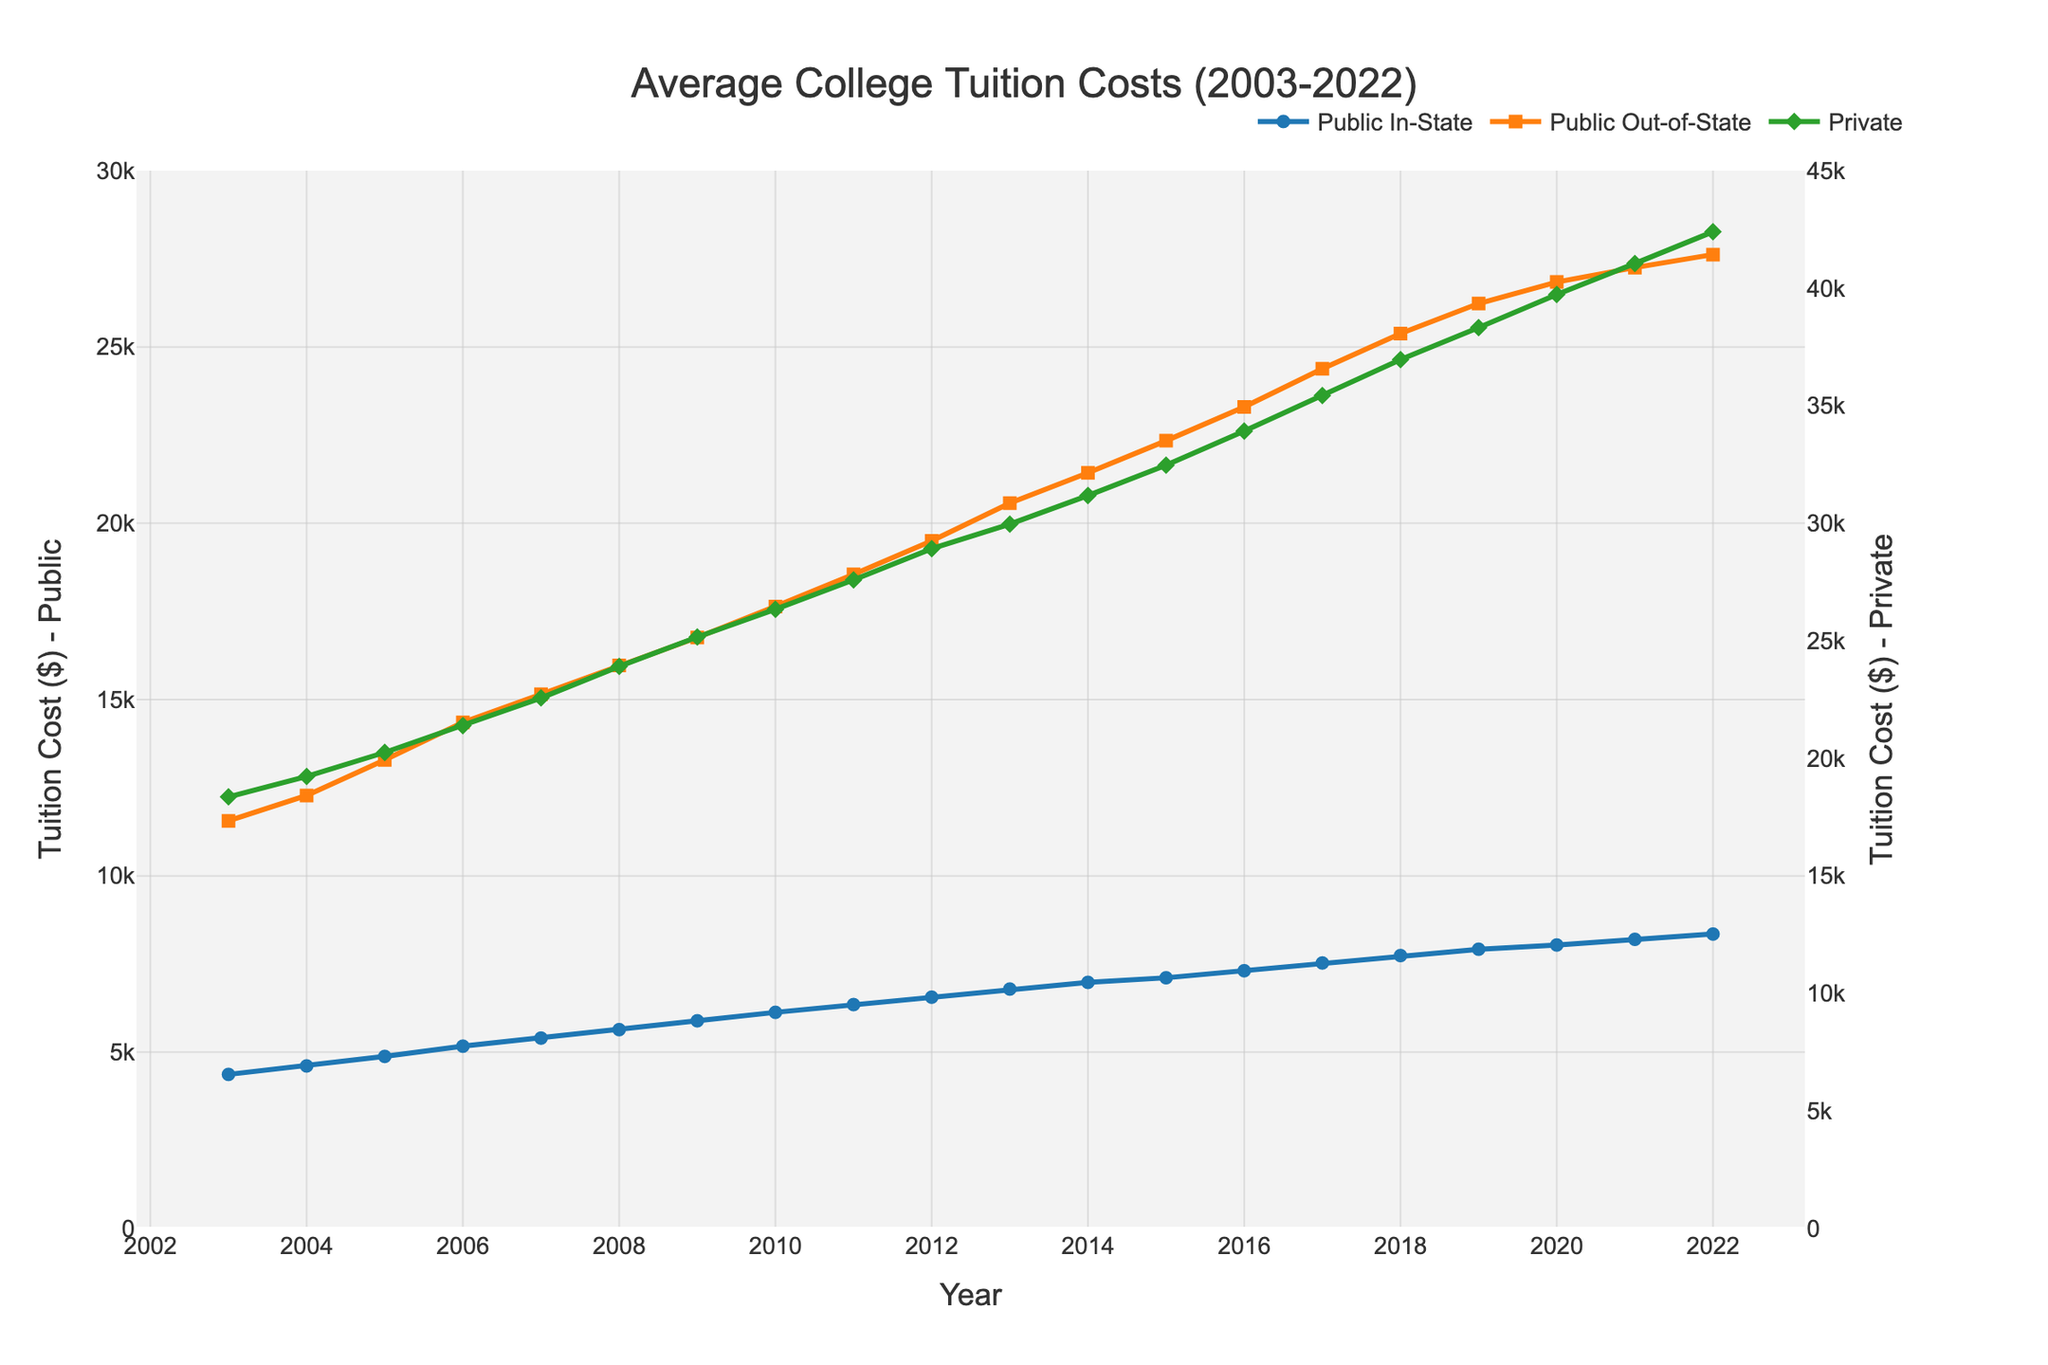What's the title of the figure? The title of the figure is written at the top center of the plot and reads "Average College Tuition Costs (2003-2022)."
Answer: Average College Tuition Costs (2003-2022) How many institution types are displayed in the figure? The figure shows plots for three different institution types: Public In-State, Public Out-of-State, and Private, which are labeled in the legend.
Answer: Three Which institution type has the highest tuition cost in 2022? The Private institution type is at the topmost line on the plot in 2022, indicating it has the highest tuition cost out of the three institution types.
Answer: Private What is the tuition cost for Public In-State institutions in 2003? To find the tuition cost for Public In-State in 2003, refer to the point on the Public In-State line (blue) that corresponds to the year 2003 on the x-axis.
Answer: $4,370 How has the tuition cost for Public Out-of-State institutions changed from 2003 to 2022? The tuition cost for Public Out-of-State institutions has increased over time: start by looking at the value in 2003 ($11,560) and then at the value in 2022 ($27,620). Subtract the 2003 value from the 2022 value to find the change.
Answer: $16,060 Which year saw the steepest increase in tuition cost for Private institutions? To determine the steepest increase, examine the changes in the slope of the Private institution line (green). The largest vertical difference between the markers from one year to the next indicates the steepest increase.
Answer: 2016 to 2017 Between Public In-State and Public Out-of-State institutions, which had a higher percentage increase in tuition cost from 2003 to 2022? Calculate percentage increase using the formula [(2022 value - 2003 value) / 2003 value] * 100. For Public In-State: [($8,350 - $4,370) / $4,370] * 100 and for Public Out-of-State: [($27,620 - $11,560) / $11,560] * 100. Compare the percentages to determine which is higher.
Answer: Public Out-of-State What's the average tuition cost for Private institutions over the years shown? Sum the tuition costs for Private institutions across all the listed years and divide by the number of years (20). Sum = 18360 + 19230 + 20250 + 21390 + 22570 + 23910 + 25160 + 26340 + 27590 + 28920 + 29960 + 31180 + 32470 + 33920 + 35430 + 36960 + 38320 + 39730 + 41050 + 42400. Average = Sum / 20.
Answer: $29,618.50 